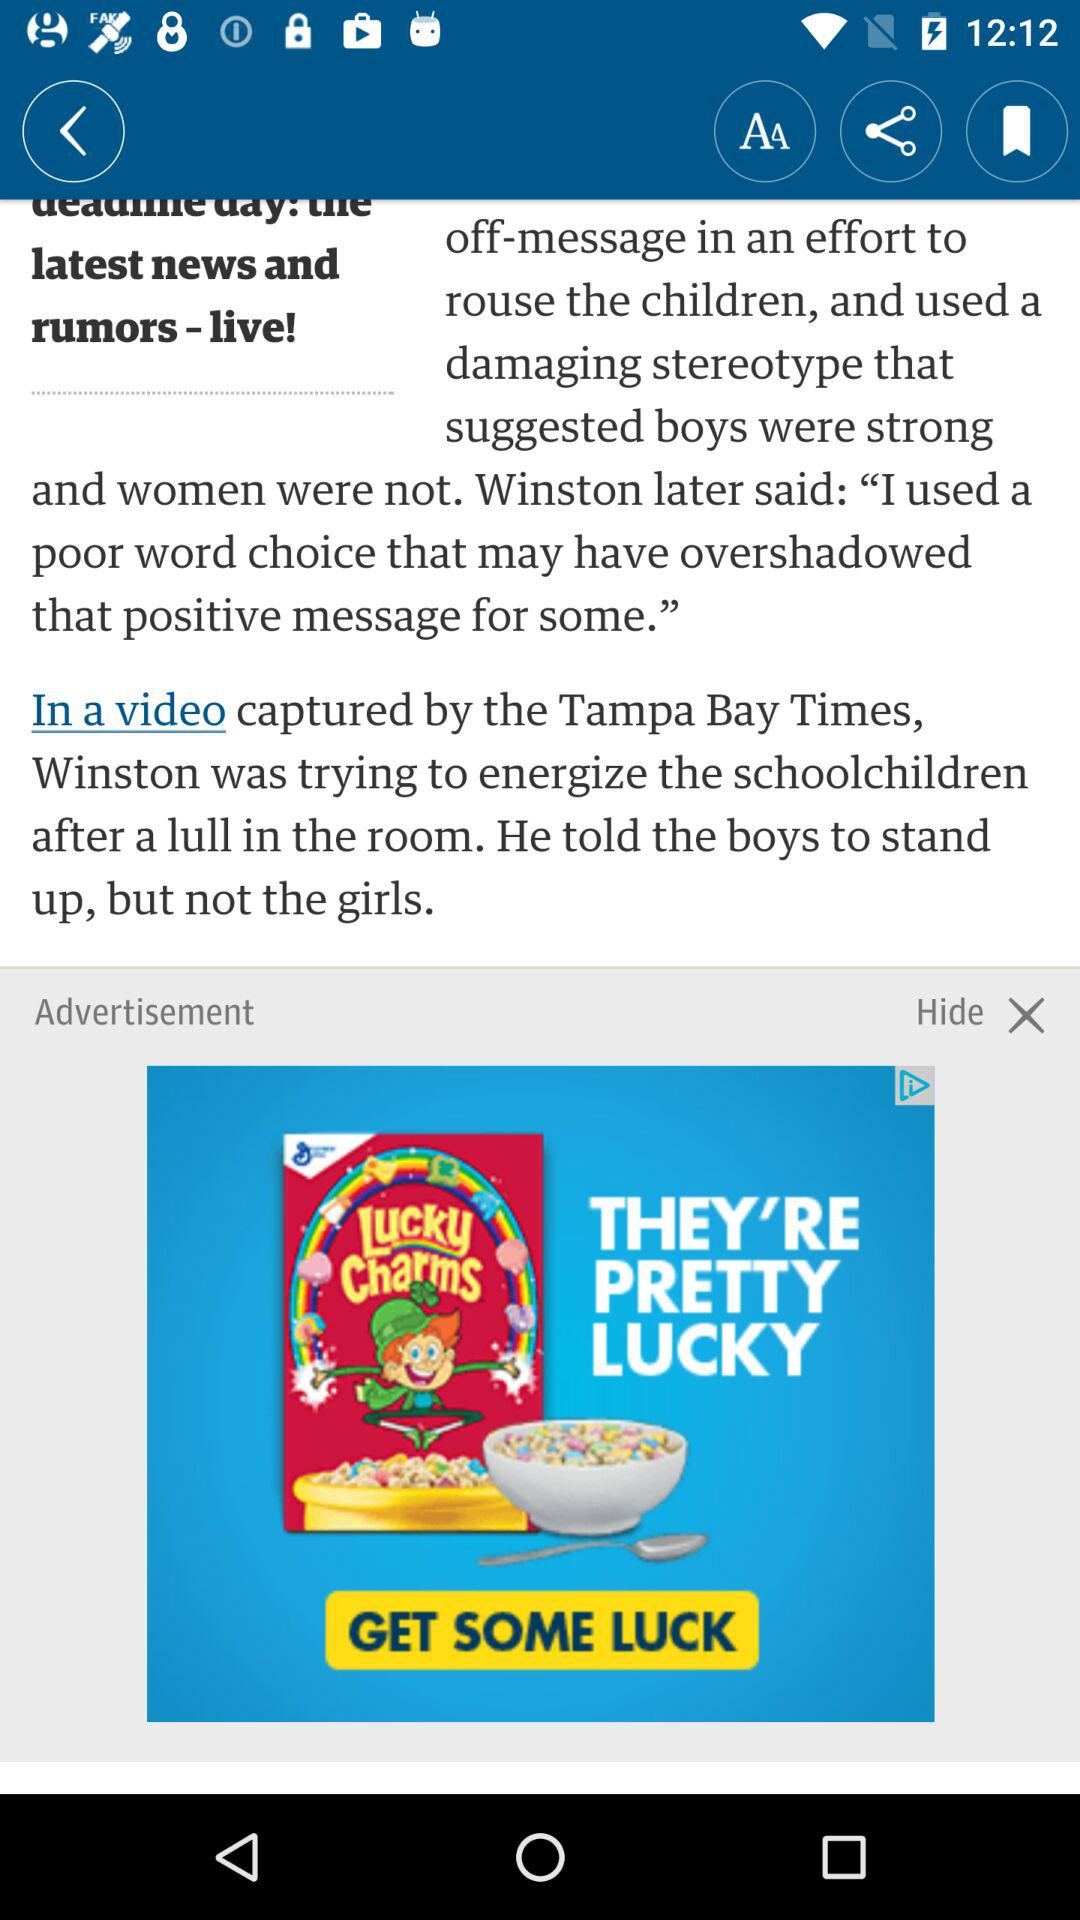What news channel captured the video? It is captured by the "Tampa Bay Times". 